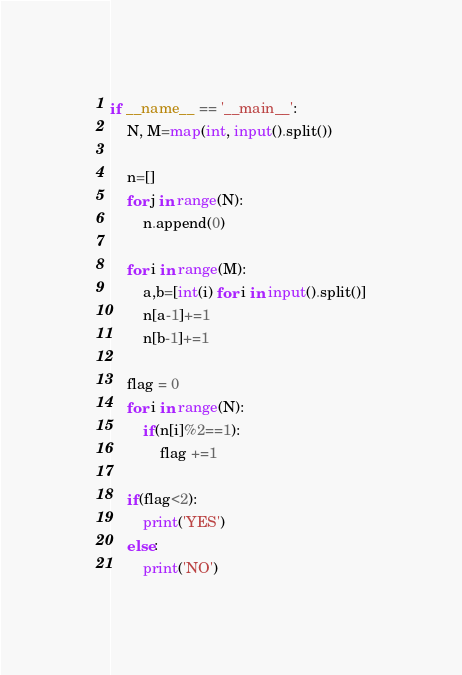<code> <loc_0><loc_0><loc_500><loc_500><_Python_>if __name__ == '__main__':
	N, M=map(int, input().split())

	n=[]
	for j in range(N):
		n.append(0)

	for i in range(M):
		a,b=[int(i) for i in input().split()]
		n[a-1]+=1
		n[b-1]+=1

	flag = 0
	for i in range(N):
		if(n[i]%2==1):
			flag +=1

	if(flag<2):
		print('YES')
	else:
		print('NO')</code> 